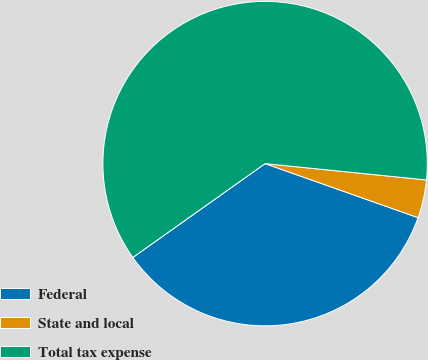Convert chart to OTSL. <chart><loc_0><loc_0><loc_500><loc_500><pie_chart><fcel>Federal<fcel>State and local<fcel>Total tax expense<nl><fcel>34.77%<fcel>3.8%<fcel>61.43%<nl></chart> 